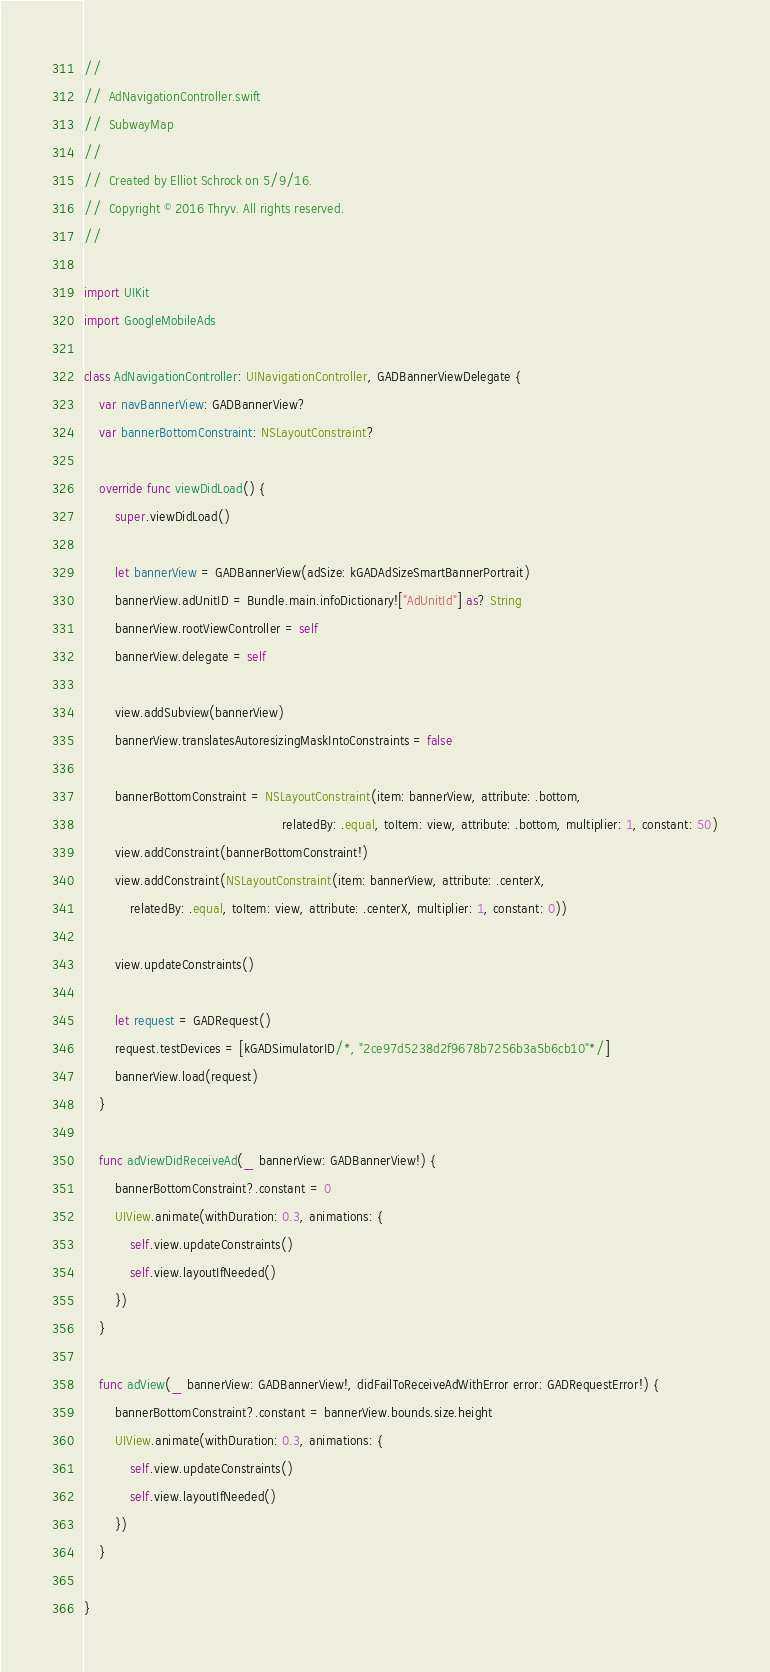<code> <loc_0><loc_0><loc_500><loc_500><_Swift_>//
//  AdNavigationController.swift
//  SubwayMap
//
//  Created by Elliot Schrock on 5/9/16.
//  Copyright © 2016 Thryv. All rights reserved.
//

import UIKit
import GoogleMobileAds

class AdNavigationController: UINavigationController, GADBannerViewDelegate {
    var navBannerView: GADBannerView?
    var bannerBottomConstraint: NSLayoutConstraint?

    override func viewDidLoad() {
        super.viewDidLoad()
        
        let bannerView = GADBannerView(adSize: kGADAdSizeSmartBannerPortrait)
        bannerView.adUnitID = Bundle.main.infoDictionary!["AdUnitId"] as? String
        bannerView.rootViewController = self
        bannerView.delegate = self
        
        view.addSubview(bannerView)
        bannerView.translatesAutoresizingMaskIntoConstraints = false

        bannerBottomConstraint = NSLayoutConstraint(item: bannerView, attribute: .bottom,
                                                    relatedBy: .equal, toItem: view, attribute: .bottom, multiplier: 1, constant: 50)
        view.addConstraint(bannerBottomConstraint!)
        view.addConstraint(NSLayoutConstraint(item: bannerView, attribute: .centerX,
            relatedBy: .equal, toItem: view, attribute: .centerX, multiplier: 1, constant: 0))

        view.updateConstraints()

        let request = GADRequest()
        request.testDevices = [kGADSimulatorID/*, "2ce97d5238d2f9678b7256b3a5b6cb10"*/]
        bannerView.load(request)
    }
    
    func adViewDidReceiveAd(_ bannerView: GADBannerView!) {
        bannerBottomConstraint?.constant = 0
        UIView.animate(withDuration: 0.3, animations: {
            self.view.updateConstraints()
            self.view.layoutIfNeeded()
        }) 
    }
    
    func adView(_ bannerView: GADBannerView!, didFailToReceiveAdWithError error: GADRequestError!) {
        bannerBottomConstraint?.constant = bannerView.bounds.size.height
        UIView.animate(withDuration: 0.3, animations: {
            self.view.updateConstraints()
            self.view.layoutIfNeeded()
        }) 
    }

}
</code> 